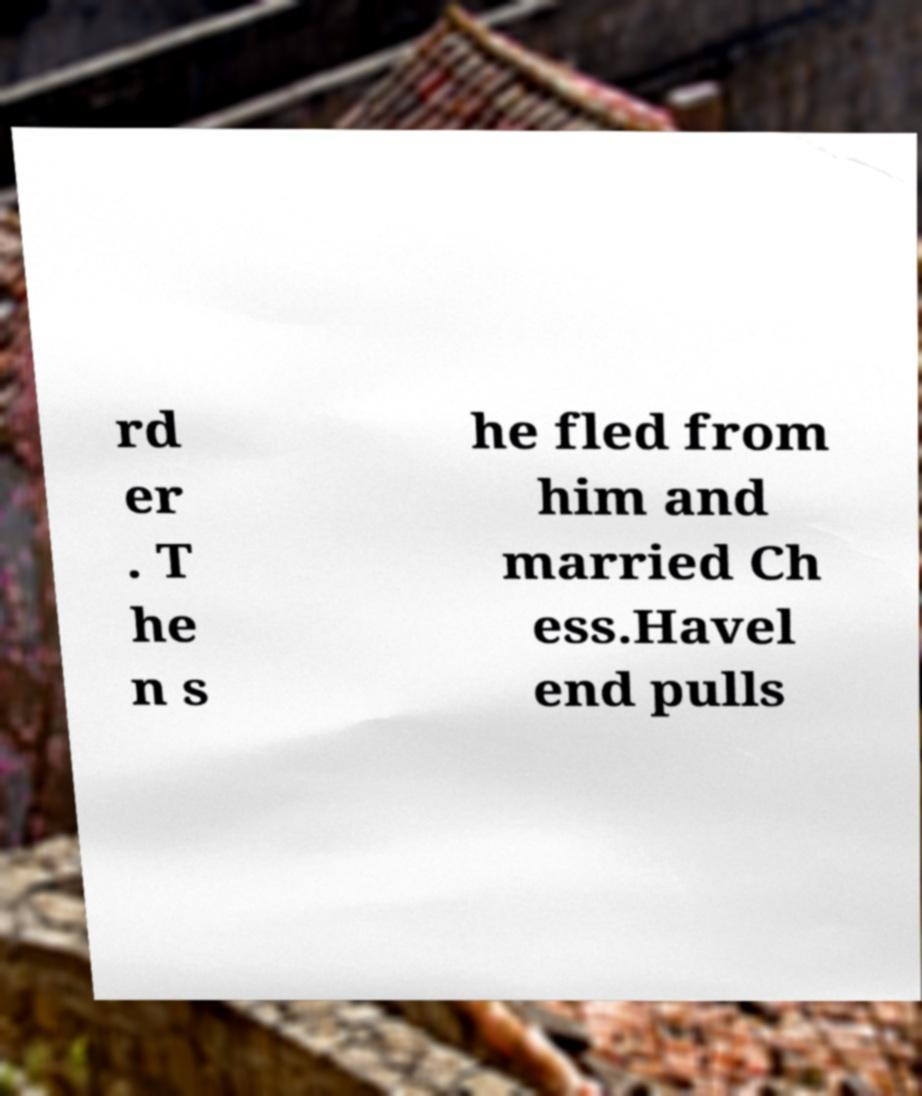What messages or text are displayed in this image? I need them in a readable, typed format. rd er . T he n s he fled from him and married Ch ess.Havel end pulls 